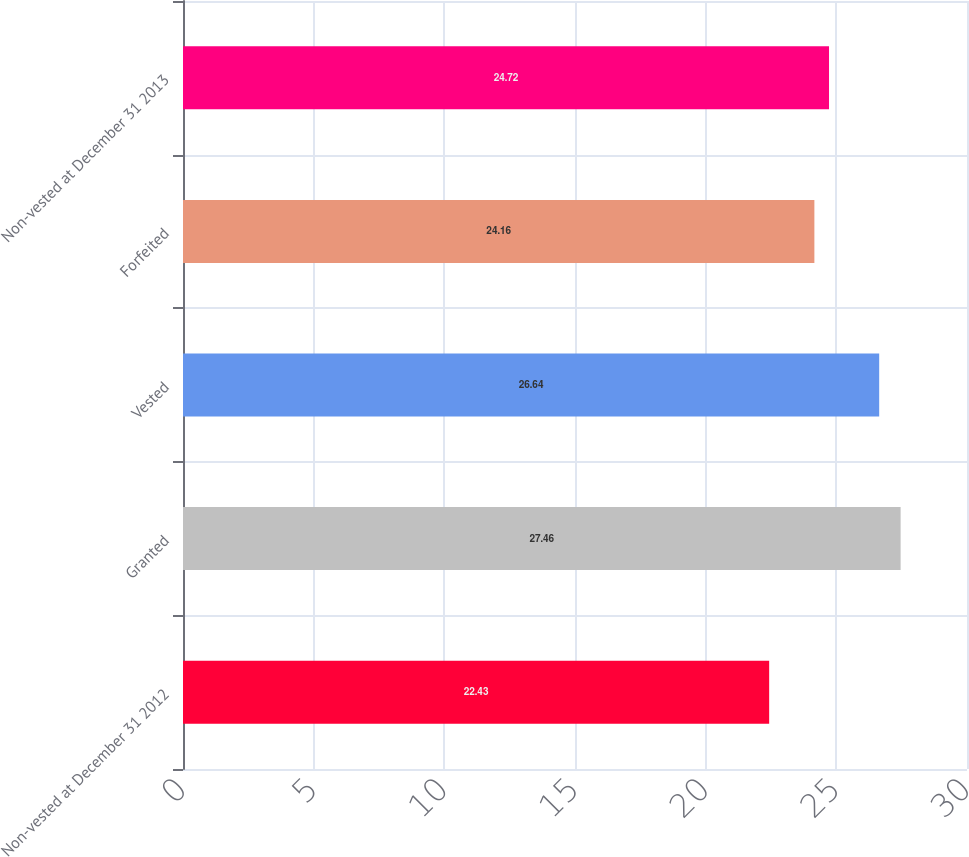Convert chart to OTSL. <chart><loc_0><loc_0><loc_500><loc_500><bar_chart><fcel>Non-vested at December 31 2012<fcel>Granted<fcel>Vested<fcel>Forfeited<fcel>Non-vested at December 31 2013<nl><fcel>22.43<fcel>27.46<fcel>26.64<fcel>24.16<fcel>24.72<nl></chart> 